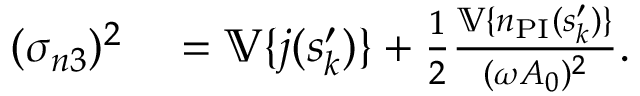Convert formula to latex. <formula><loc_0><loc_0><loc_500><loc_500>\begin{array} { r l } { ( \sigma _ { n 3 } ) ^ { 2 } } & = \mathbb { V } \{ j ( s _ { k } ^ { \prime } ) \} + \frac { 1 } { 2 } \frac { \mathbb { V } \{ n _ { P I } ( s _ { k } ^ { \prime } ) \} } { ( \omega A _ { 0 } ) ^ { 2 } } . } \end{array}</formula> 